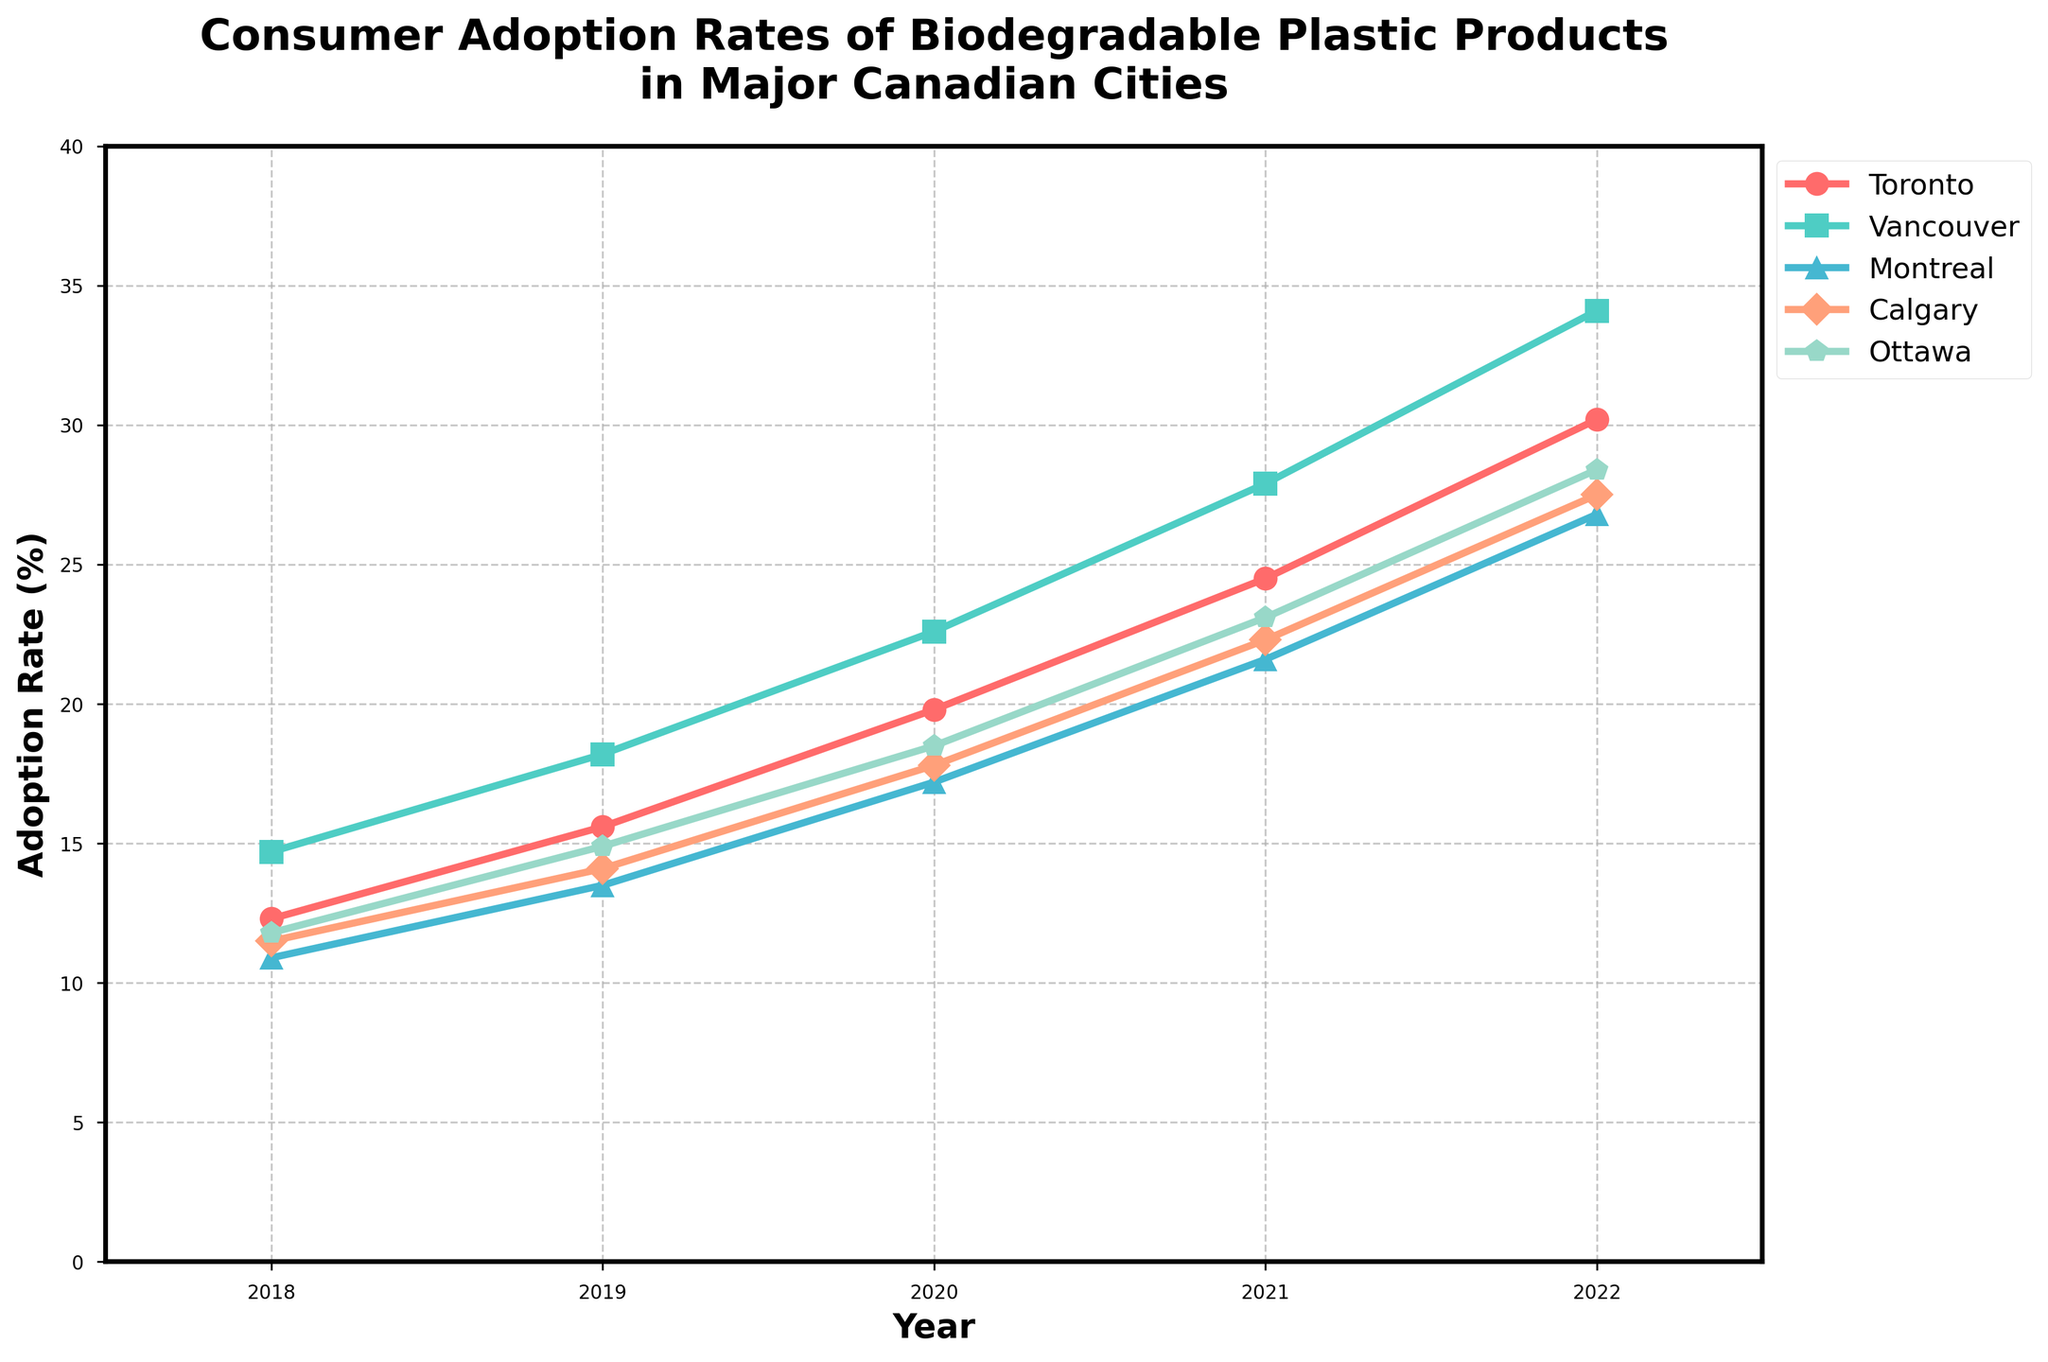What is the adoption rate of biodegradable plastic products in Toronto in 2019? Look at the point for Toronto in 2019 on the chart, it is marked with a specific color and marker. The y-axis shows the adoption rates. The point for Toronto in 2019 has an adoption rate of 15.6%.
Answer: 15.6% What is the difference in adoption rates between Vancouver and Calgary in 2022? Locate the points for Vancouver and Calgary in 2022. Vancouver has an adoption rate of 34.1% and Calgary has 27.5%. The difference is 34.1 - 27.5 = 6.6%.
Answer: 6.6% Which city had the highest adoption rate in 2022 and what was it? Check the adoption rates in 2022 for all cities and find the highest one. Vancouver has the highest rate at 34.1%.
Answer: Vancouver, 34.1% Between 2018 and 2022, which city showed the largest increase in adoption rates? Calculate the increase for each city by subtracting the 2018 rate from the 2022 rate. Toronto: 30.2 - 12.3 = 17.9, Vancouver: 34.1 - 14.7 = 19.4, Montreal: 26.8 - 10.9 = 15.9, Calgary: 27.5 - 11.5 = 16.0, Ottawa: 28.4 - 11.8 = 16.6. Vancouver showed the largest increase of 19.4%.
Answer: Vancouver What is the average adoption rate of biodegradable plastics in Montreal for the years given? Add the adoption rates of Montreal in all the years and divide by the number of years. (10.9 + 13.5 + 17.2 + 21.6 + 26.8) / 5 = 90 / 5 = 18%.
Answer: 18% In which year did Calgary overtake Ottawa in adoption rates? Compare the adoption rates of Calgary and Ottawa year by year. In 2020, Calgary had 17.8% and Ottawa had 18.5%, but in 2021, Calgary had 22.3% and Ottawa had 23.1%. Therefore, Calgary overtook Ottawa in 2021.
Answer: 2021 How much did the adoption rate of biodegradable plastic products increase in Toronto between 2018 and 2022? Subtract the adoption rate in 2018 from the rate in 2022 for Toronto. 30.2 - 12.3 = 17.9%.
Answer: 17.9% Which city had the lowest adoption rate in 2018 and what was it? Look at the adoption rates for all cities in 2018 and find the lowest one. Montreal had the lowest rate at 10.9%.
Answer: Montreal, 10.9% What is the median adoption rate for Ottawa from 2018 to 2022? Arrange the adoption rates for Ottawa in numerical order and find the middle value. The rates are (11.8, 14.9, 18.5, 23.1, 28.4). The median is the middle value, 18.5.
Answer: 18.5% 